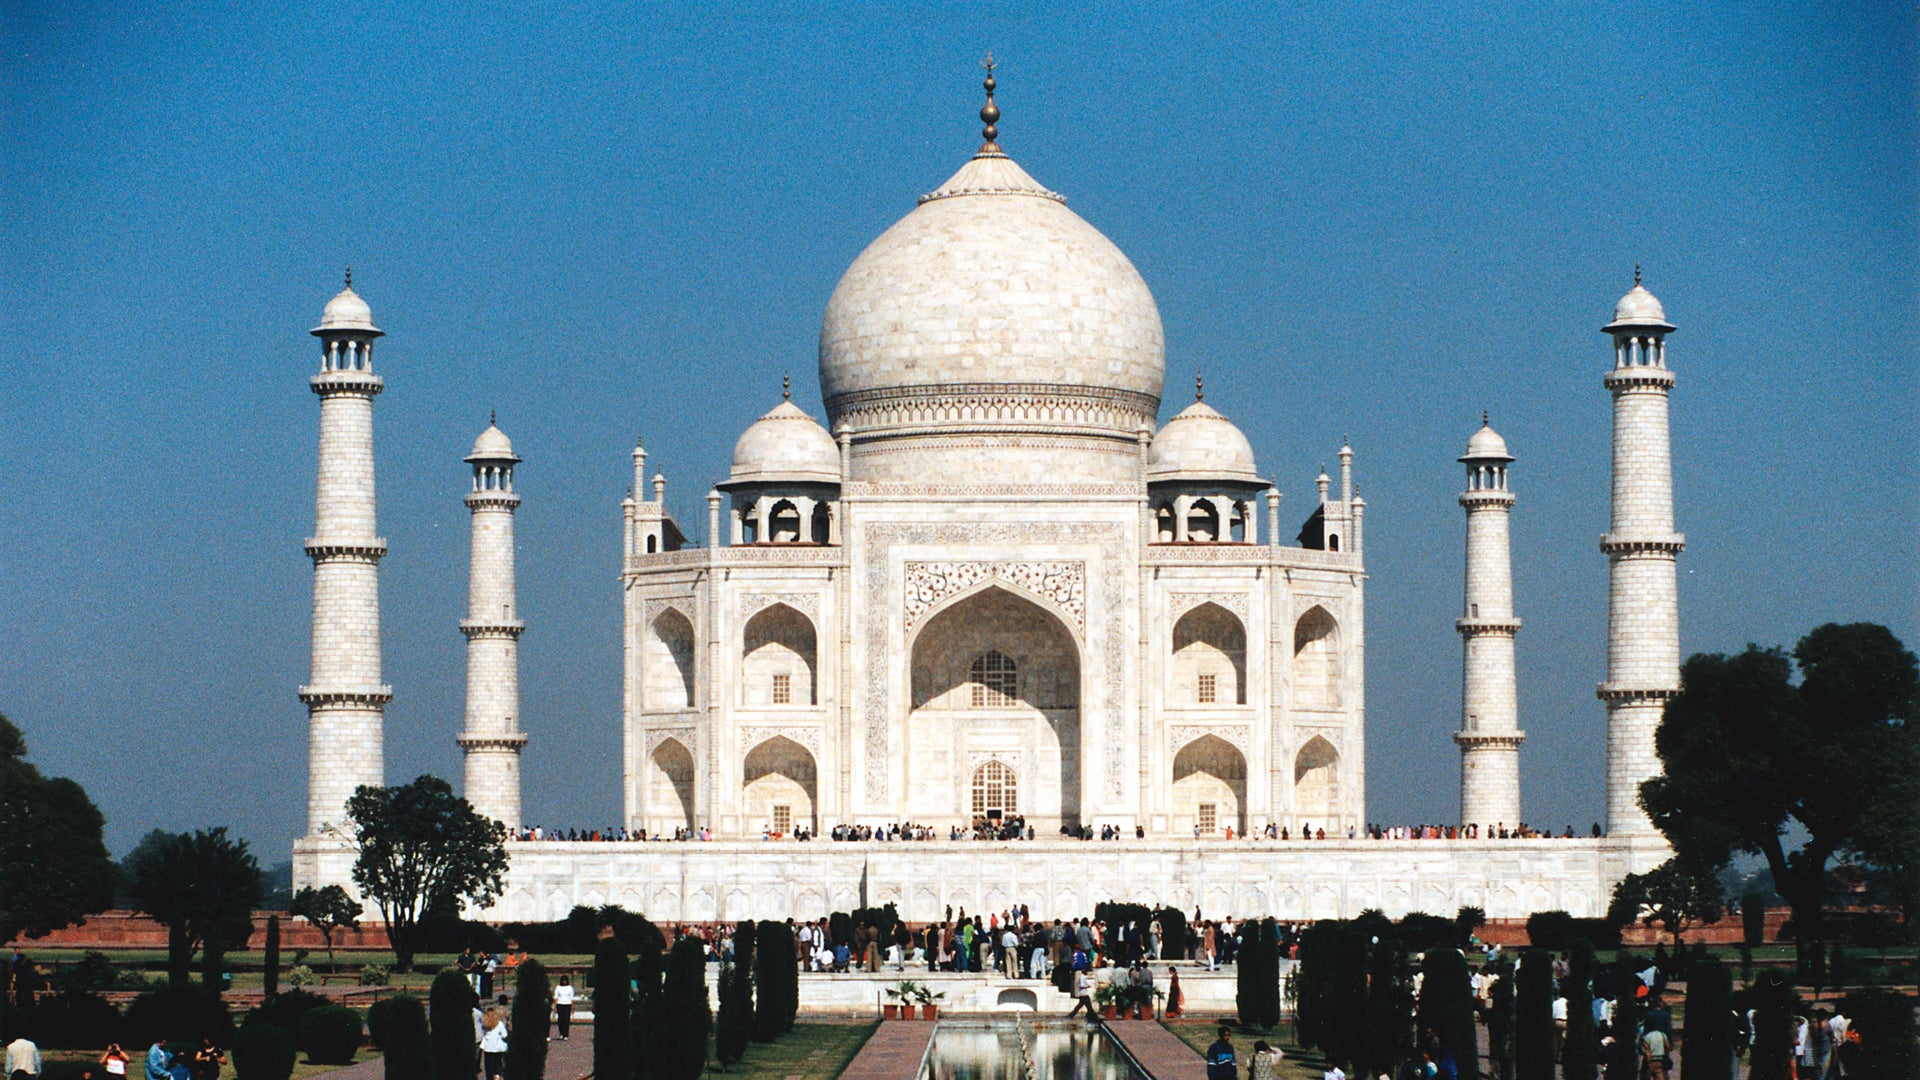Could you tell me more about the architectural style of the Taj Mahal? Absolutely. The Taj Mahal is a prime example of Mughal architecture, which is a blend of Indian, Persian, and Islamic influences. Its architecture features a symmetrical layout, large domes, and extensive use of white marble inlaid with semi-precious stones. The mausoleum uses vaulted arches, geometric patterns, and intricate Pietra dura artwork. The four minarets, designed slightly outwards, provide not only grace but also stability. The complex also includes other significant elements, like a mosque and a guest house, which adhere to the principles of symmetry and harmony that define this style. 